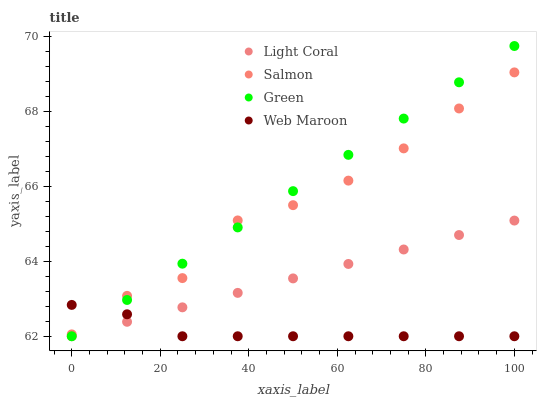Does Web Maroon have the minimum area under the curve?
Answer yes or no. Yes. Does Green have the maximum area under the curve?
Answer yes or no. Yes. Does Salmon have the minimum area under the curve?
Answer yes or no. No. Does Salmon have the maximum area under the curve?
Answer yes or no. No. Is Light Coral the smoothest?
Answer yes or no. Yes. Is Salmon the roughest?
Answer yes or no. Yes. Is Green the smoothest?
Answer yes or no. No. Is Green the roughest?
Answer yes or no. No. Does Light Coral have the lowest value?
Answer yes or no. Yes. Does Salmon have the lowest value?
Answer yes or no. No. Does Green have the highest value?
Answer yes or no. Yes. Does Salmon have the highest value?
Answer yes or no. No. Is Light Coral less than Salmon?
Answer yes or no. Yes. Is Salmon greater than Light Coral?
Answer yes or no. Yes. Does Web Maroon intersect Light Coral?
Answer yes or no. Yes. Is Web Maroon less than Light Coral?
Answer yes or no. No. Is Web Maroon greater than Light Coral?
Answer yes or no. No. Does Light Coral intersect Salmon?
Answer yes or no. No. 